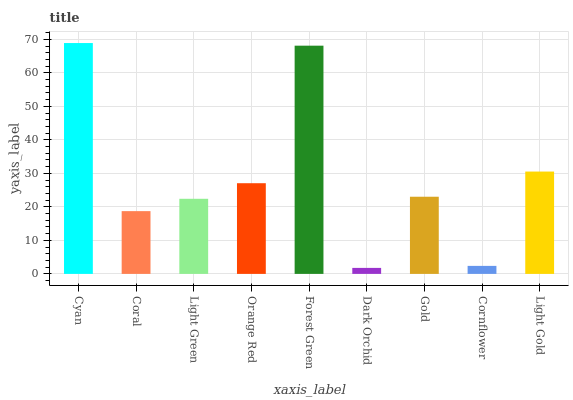Is Dark Orchid the minimum?
Answer yes or no. Yes. Is Cyan the maximum?
Answer yes or no. Yes. Is Coral the minimum?
Answer yes or no. No. Is Coral the maximum?
Answer yes or no. No. Is Cyan greater than Coral?
Answer yes or no. Yes. Is Coral less than Cyan?
Answer yes or no. Yes. Is Coral greater than Cyan?
Answer yes or no. No. Is Cyan less than Coral?
Answer yes or no. No. Is Gold the high median?
Answer yes or no. Yes. Is Gold the low median?
Answer yes or no. Yes. Is Dark Orchid the high median?
Answer yes or no. No. Is Coral the low median?
Answer yes or no. No. 